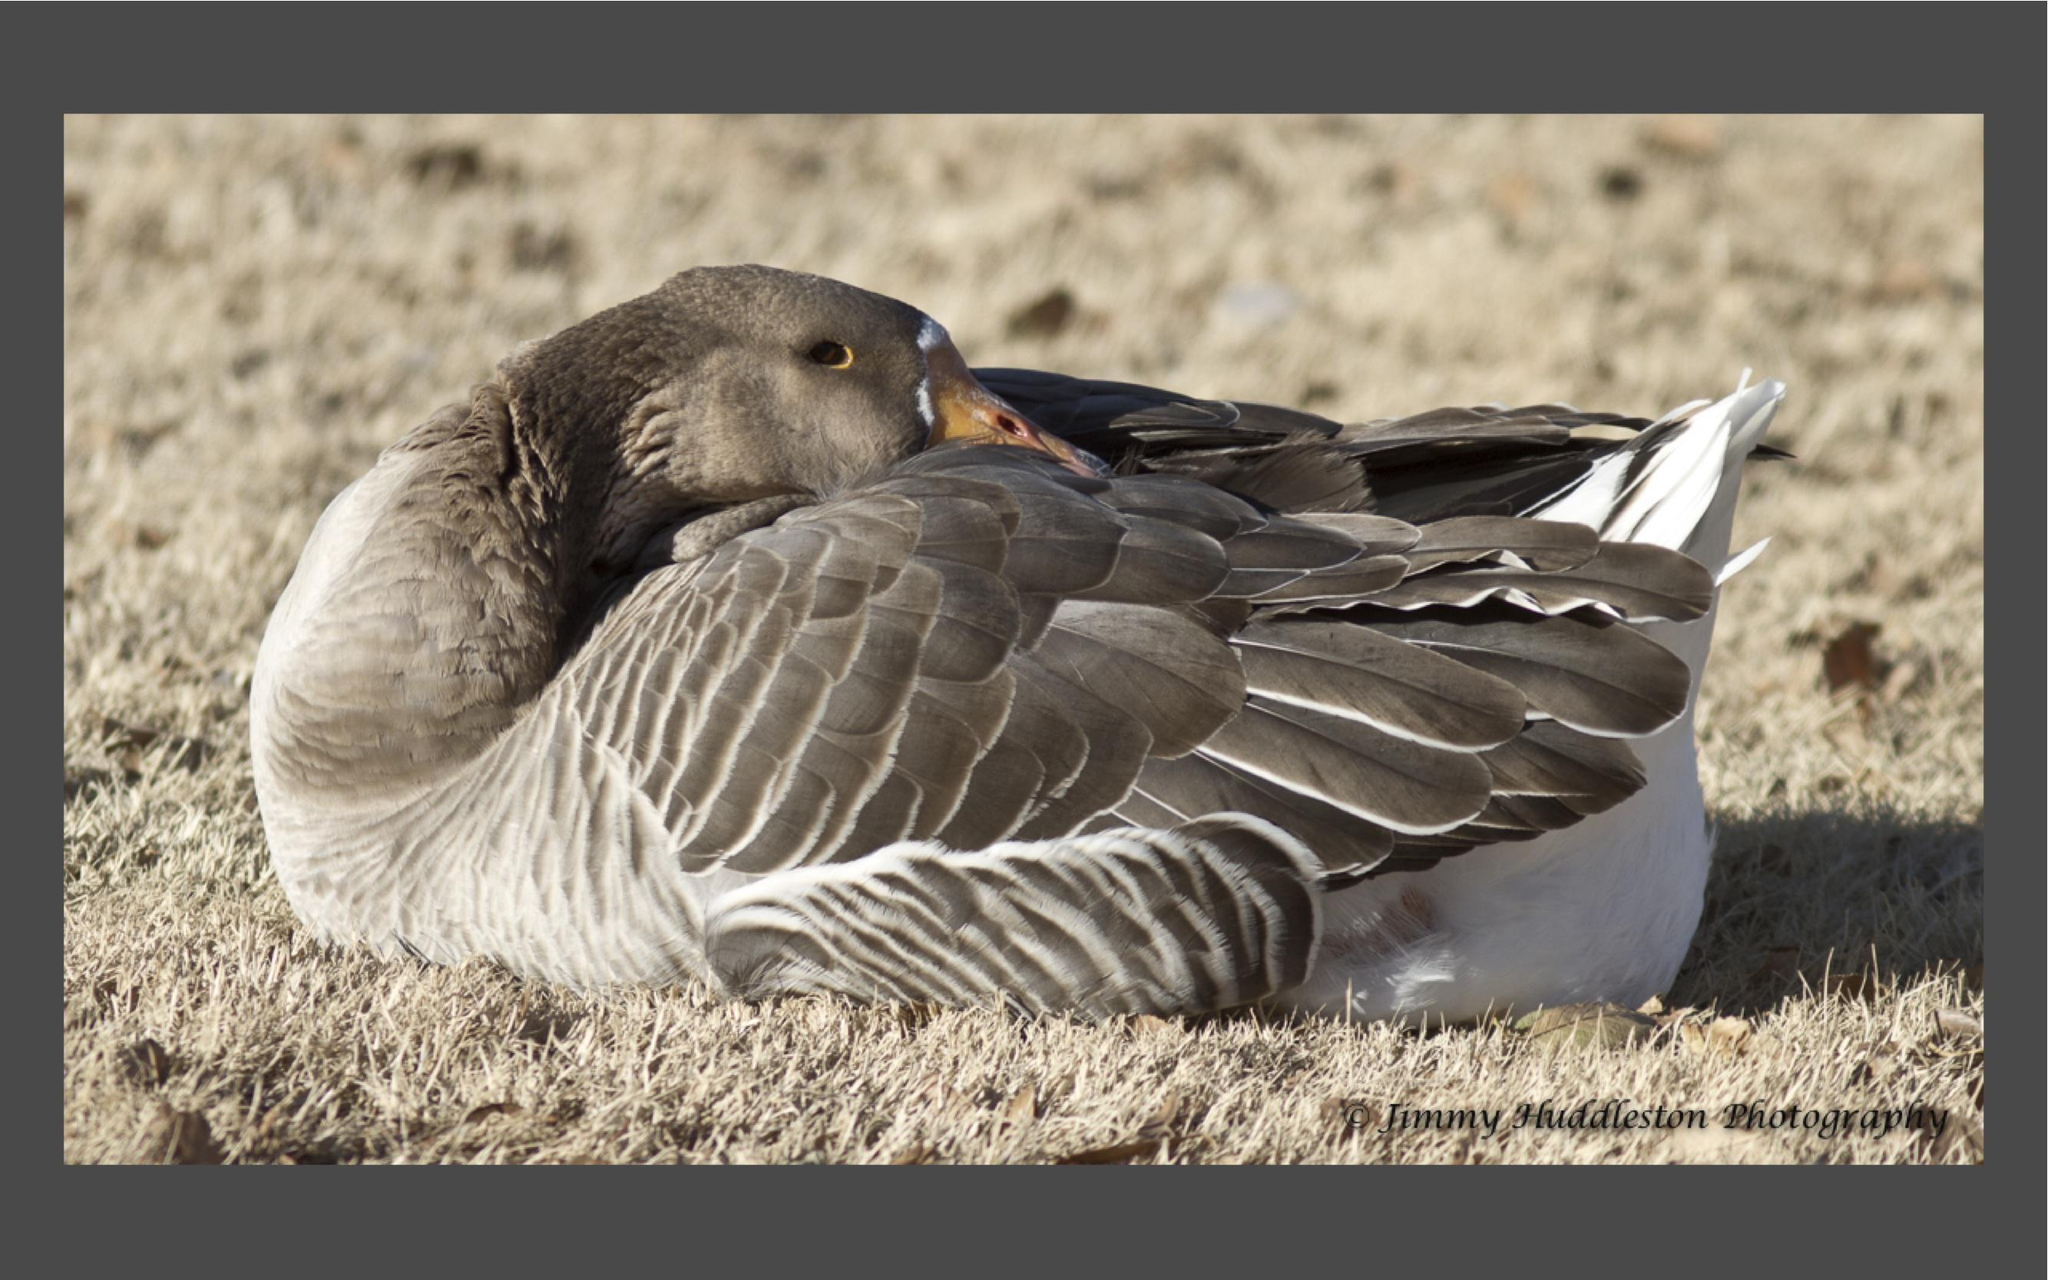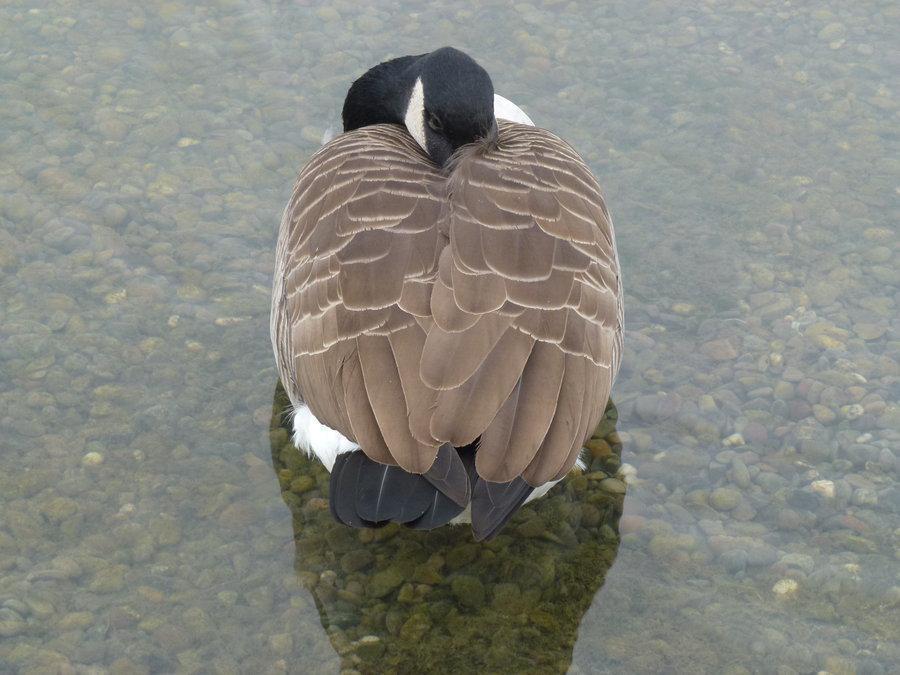The first image is the image on the left, the second image is the image on the right. Examine the images to the left and right. Is the description "The left image contains at least two ducks." accurate? Answer yes or no. No. The first image is the image on the left, the second image is the image on the right. Analyze the images presented: Is the assertion "Each image shows one goose, and in one image the goose is on water and posed with its neck curved back." valid? Answer yes or no. Yes. 